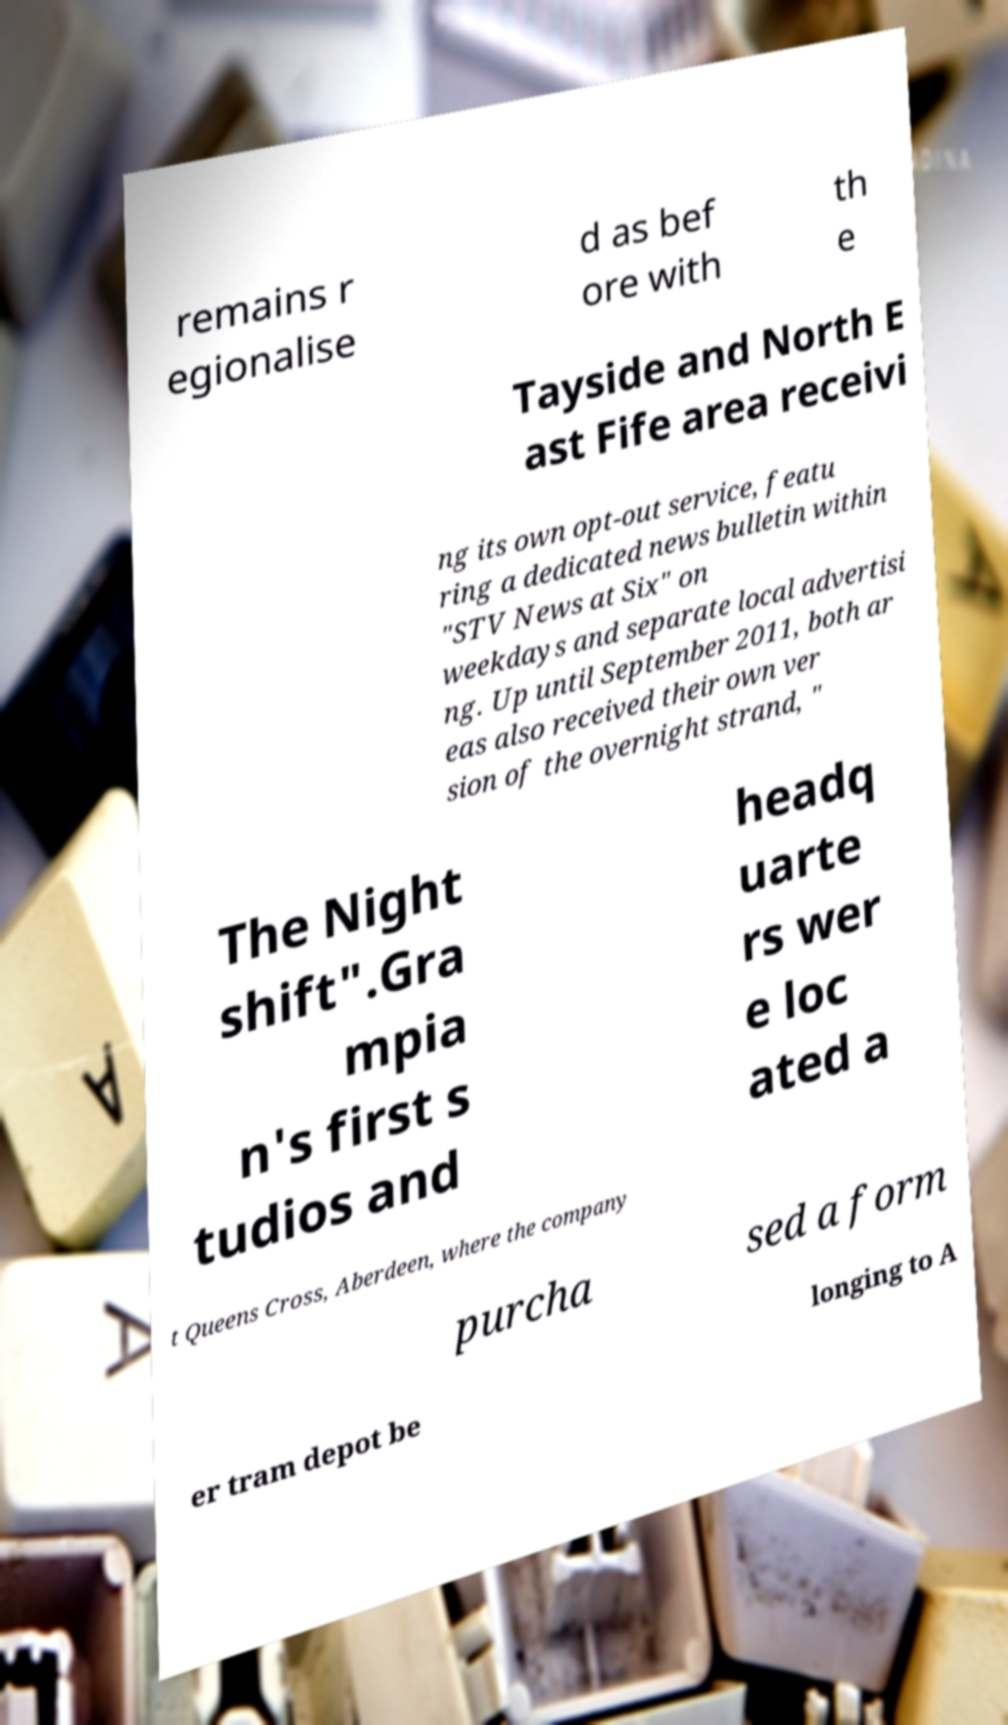There's text embedded in this image that I need extracted. Can you transcribe it verbatim? remains r egionalise d as bef ore with th e Tayside and North E ast Fife area receivi ng its own opt-out service, featu ring a dedicated news bulletin within "STV News at Six" on weekdays and separate local advertisi ng. Up until September 2011, both ar eas also received their own ver sion of the overnight strand, " The Night shift".Gra mpia n's first s tudios and headq uarte rs wer e loc ated a t Queens Cross, Aberdeen, where the company purcha sed a form er tram depot be longing to A 